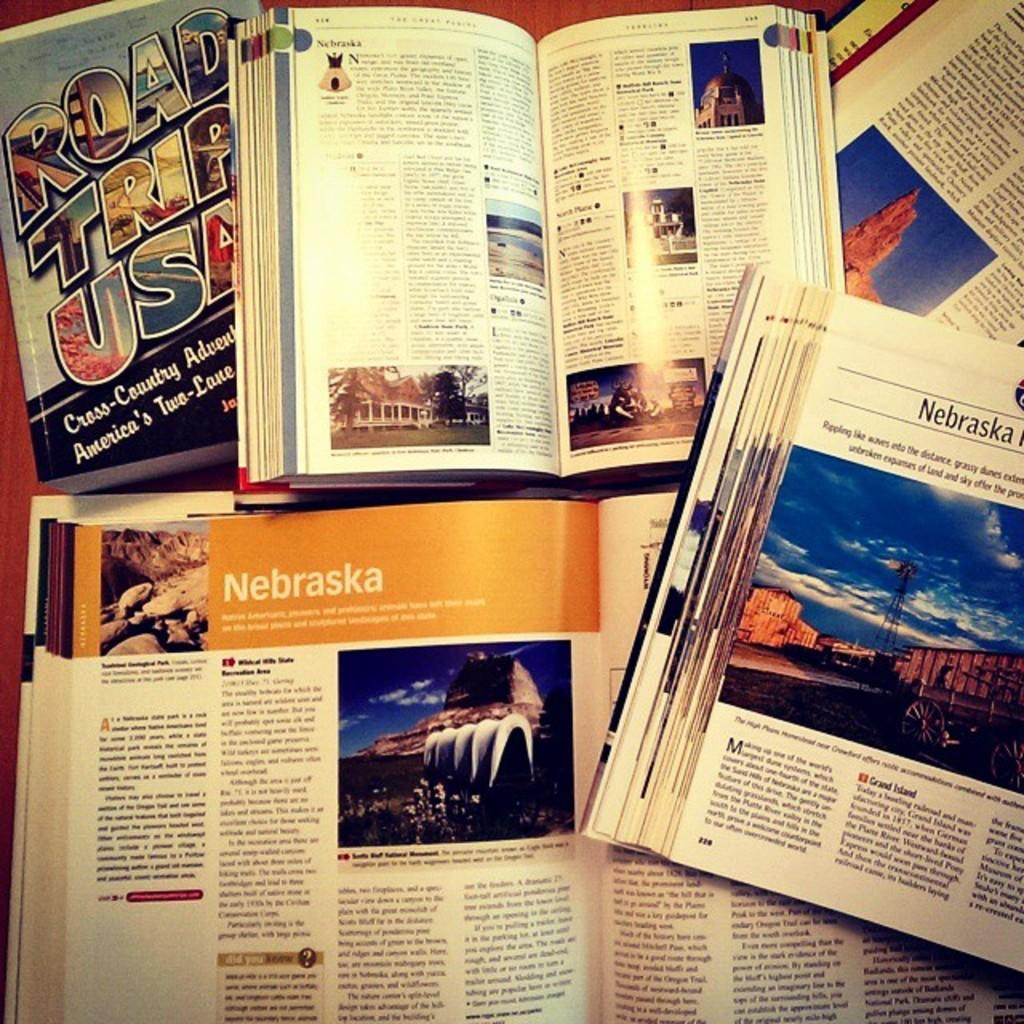Provide a one-sentence caption for the provided image. A book titled Road Trip USA is opened to the chapter for the state of Nebraska. 